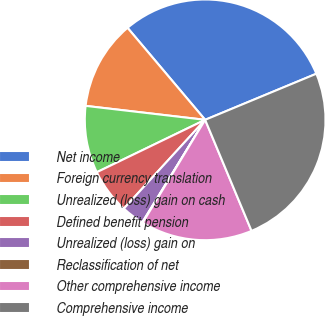Convert chart to OTSL. <chart><loc_0><loc_0><loc_500><loc_500><pie_chart><fcel>Net income<fcel>Foreign currency translation<fcel>Unrealized (loss) gain on cash<fcel>Defined benefit pension<fcel>Unrealized (loss) gain on<fcel>Reclassification of net<fcel>Other comprehensive income<fcel>Comprehensive income<nl><fcel>29.9%<fcel>12.0%<fcel>9.02%<fcel>6.03%<fcel>3.05%<fcel>0.07%<fcel>14.98%<fcel>24.96%<nl></chart> 